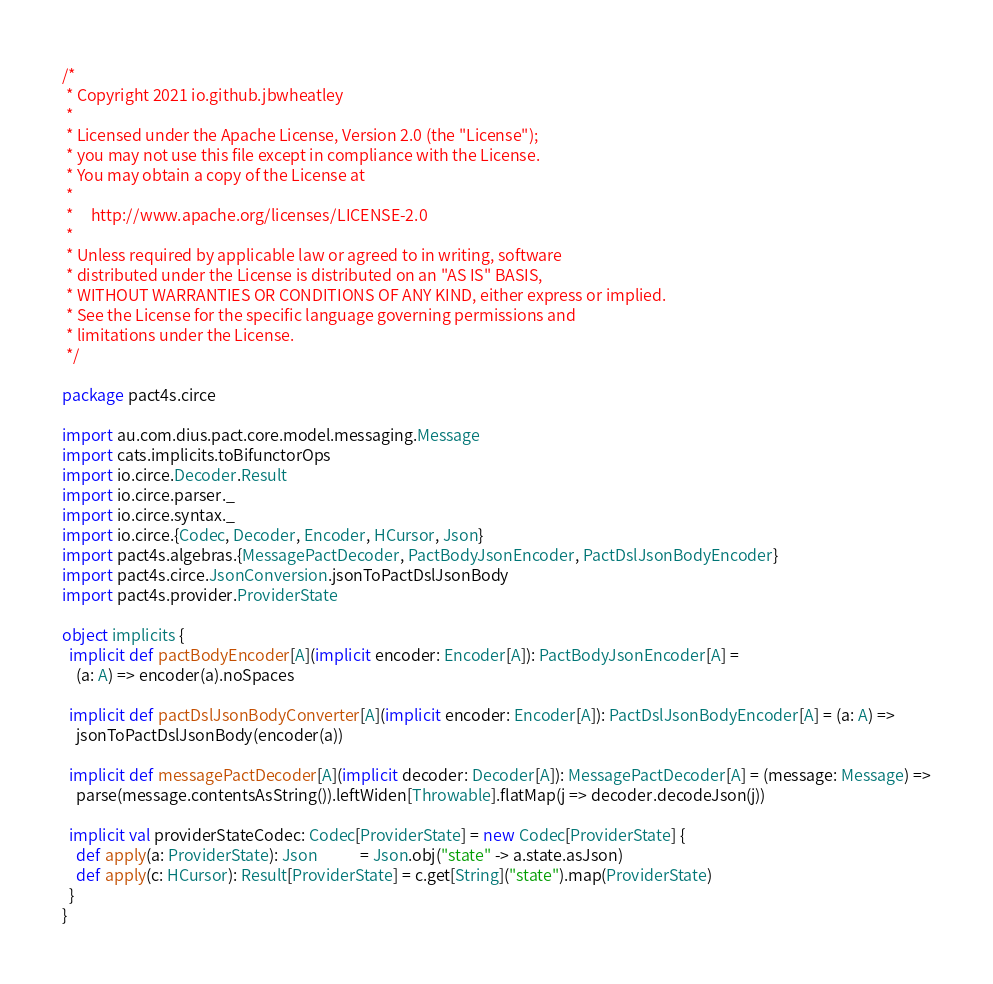Convert code to text. <code><loc_0><loc_0><loc_500><loc_500><_Scala_>/*
 * Copyright 2021 io.github.jbwheatley
 *
 * Licensed under the Apache License, Version 2.0 (the "License");
 * you may not use this file except in compliance with the License.
 * You may obtain a copy of the License at
 *
 *     http://www.apache.org/licenses/LICENSE-2.0
 *
 * Unless required by applicable law or agreed to in writing, software
 * distributed under the License is distributed on an "AS IS" BASIS,
 * WITHOUT WARRANTIES OR CONDITIONS OF ANY KIND, either express or implied.
 * See the License for the specific language governing permissions and
 * limitations under the License.
 */

package pact4s.circe

import au.com.dius.pact.core.model.messaging.Message
import cats.implicits.toBifunctorOps
import io.circe.Decoder.Result
import io.circe.parser._
import io.circe.syntax._
import io.circe.{Codec, Decoder, Encoder, HCursor, Json}
import pact4s.algebras.{MessagePactDecoder, PactBodyJsonEncoder, PactDslJsonBodyEncoder}
import pact4s.circe.JsonConversion.jsonToPactDslJsonBody
import pact4s.provider.ProviderState

object implicits {
  implicit def pactBodyEncoder[A](implicit encoder: Encoder[A]): PactBodyJsonEncoder[A] =
    (a: A) => encoder(a).noSpaces

  implicit def pactDslJsonBodyConverter[A](implicit encoder: Encoder[A]): PactDslJsonBodyEncoder[A] = (a: A) =>
    jsonToPactDslJsonBody(encoder(a))

  implicit def messagePactDecoder[A](implicit decoder: Decoder[A]): MessagePactDecoder[A] = (message: Message) =>
    parse(message.contentsAsString()).leftWiden[Throwable].flatMap(j => decoder.decodeJson(j))

  implicit val providerStateCodec: Codec[ProviderState] = new Codec[ProviderState] {
    def apply(a: ProviderState): Json            = Json.obj("state" -> a.state.asJson)
    def apply(c: HCursor): Result[ProviderState] = c.get[String]("state").map(ProviderState)
  }
}
</code> 